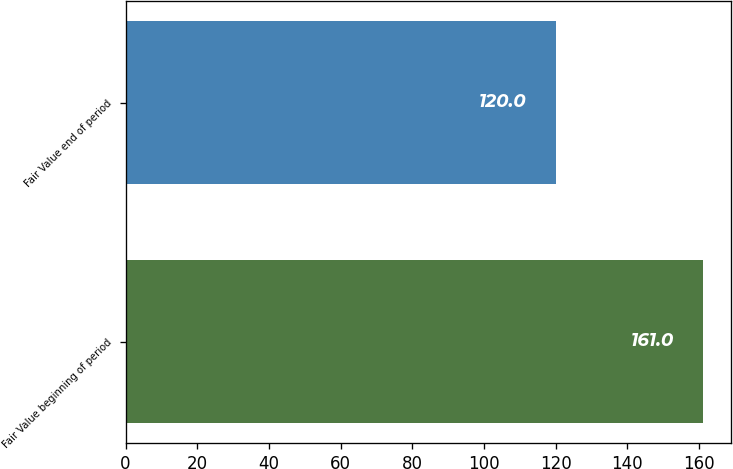<chart> <loc_0><loc_0><loc_500><loc_500><bar_chart><fcel>Fair Value beginning of period<fcel>Fair Value end of period<nl><fcel>161<fcel>120<nl></chart> 